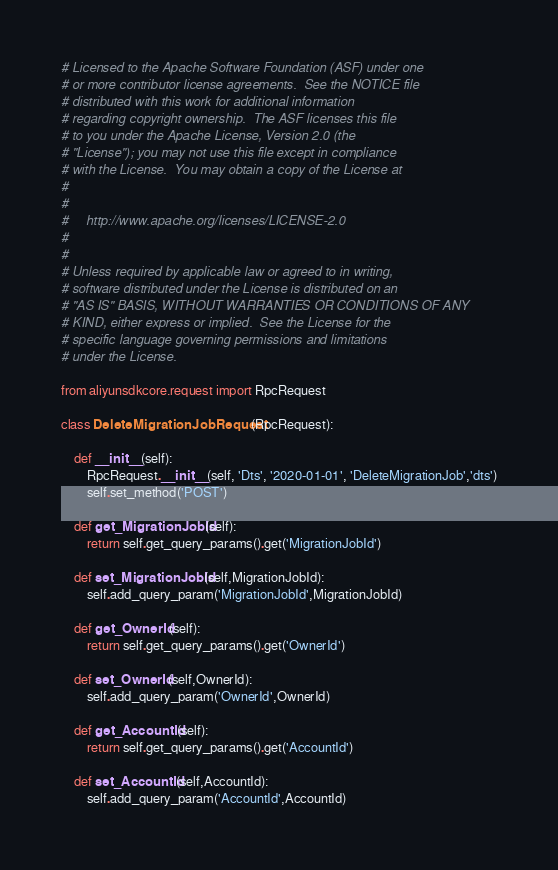<code> <loc_0><loc_0><loc_500><loc_500><_Python_># Licensed to the Apache Software Foundation (ASF) under one
# or more contributor license agreements.  See the NOTICE file
# distributed with this work for additional information
# regarding copyright ownership.  The ASF licenses this file
# to you under the Apache License, Version 2.0 (the
# "License"); you may not use this file except in compliance
# with the License.  You may obtain a copy of the License at
#
#
#     http://www.apache.org/licenses/LICENSE-2.0
#
#
# Unless required by applicable law or agreed to in writing,
# software distributed under the License is distributed on an
# "AS IS" BASIS, WITHOUT WARRANTIES OR CONDITIONS OF ANY
# KIND, either express or implied.  See the License for the
# specific language governing permissions and limitations
# under the License.

from aliyunsdkcore.request import RpcRequest

class DeleteMigrationJobRequest(RpcRequest):

	def __init__(self):
		RpcRequest.__init__(self, 'Dts', '2020-01-01', 'DeleteMigrationJob','dts')
		self.set_method('POST')

	def get_MigrationJobId(self):
		return self.get_query_params().get('MigrationJobId')

	def set_MigrationJobId(self,MigrationJobId):
		self.add_query_param('MigrationJobId',MigrationJobId)

	def get_OwnerId(self):
		return self.get_query_params().get('OwnerId')

	def set_OwnerId(self,OwnerId):
		self.add_query_param('OwnerId',OwnerId)

	def get_AccountId(self):
		return self.get_query_params().get('AccountId')

	def set_AccountId(self,AccountId):
		self.add_query_param('AccountId',AccountId)</code> 